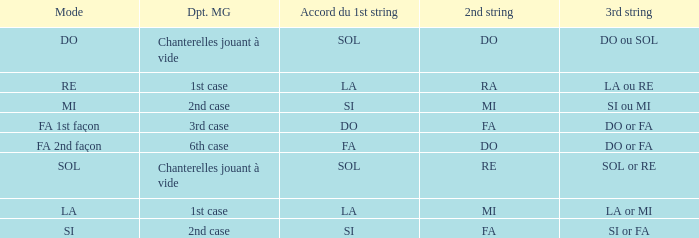For a 1st string of si Accord du and a 2nd string of mi what is the 3rd string? SI ou MI. 